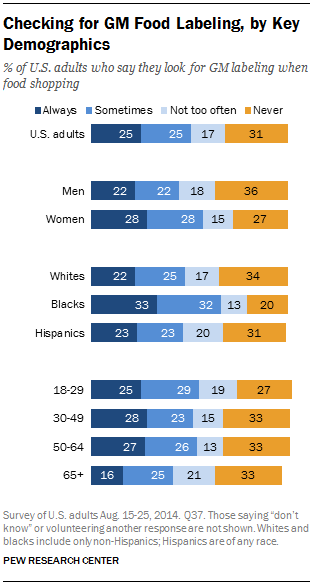Specify some key components in this picture. According to the given statistic, only 0.27% of women never check for GM food labeling. A study found that people from different racial backgrounds have varying levels of concern about genetically modified (GM) food labeling. The study revealed that a majority of 78% of people from one race always check for GM food labeling before purchasing. 